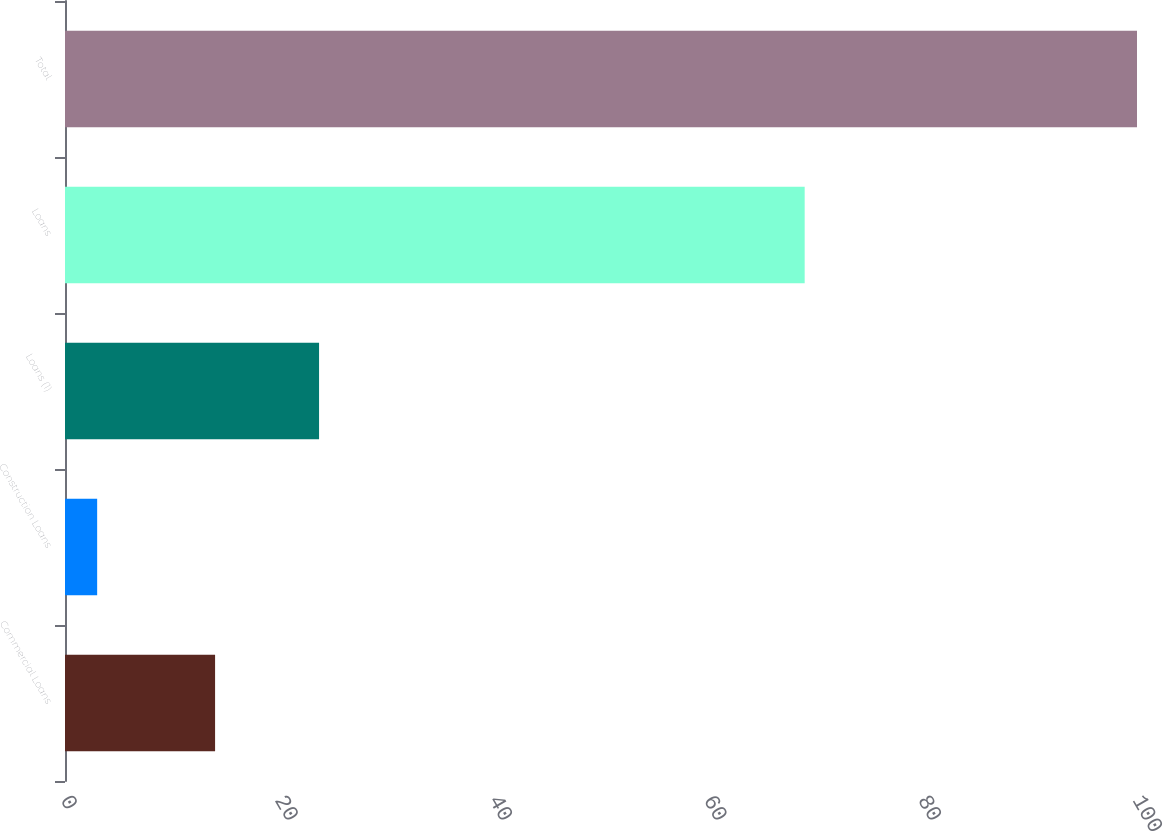Convert chart. <chart><loc_0><loc_0><loc_500><loc_500><bar_chart><fcel>Commercial Loans<fcel>Construction Loans<fcel>Loans (1)<fcel>Loans<fcel>Total<nl><fcel>14<fcel>3<fcel>23.7<fcel>69<fcel>100<nl></chart> 